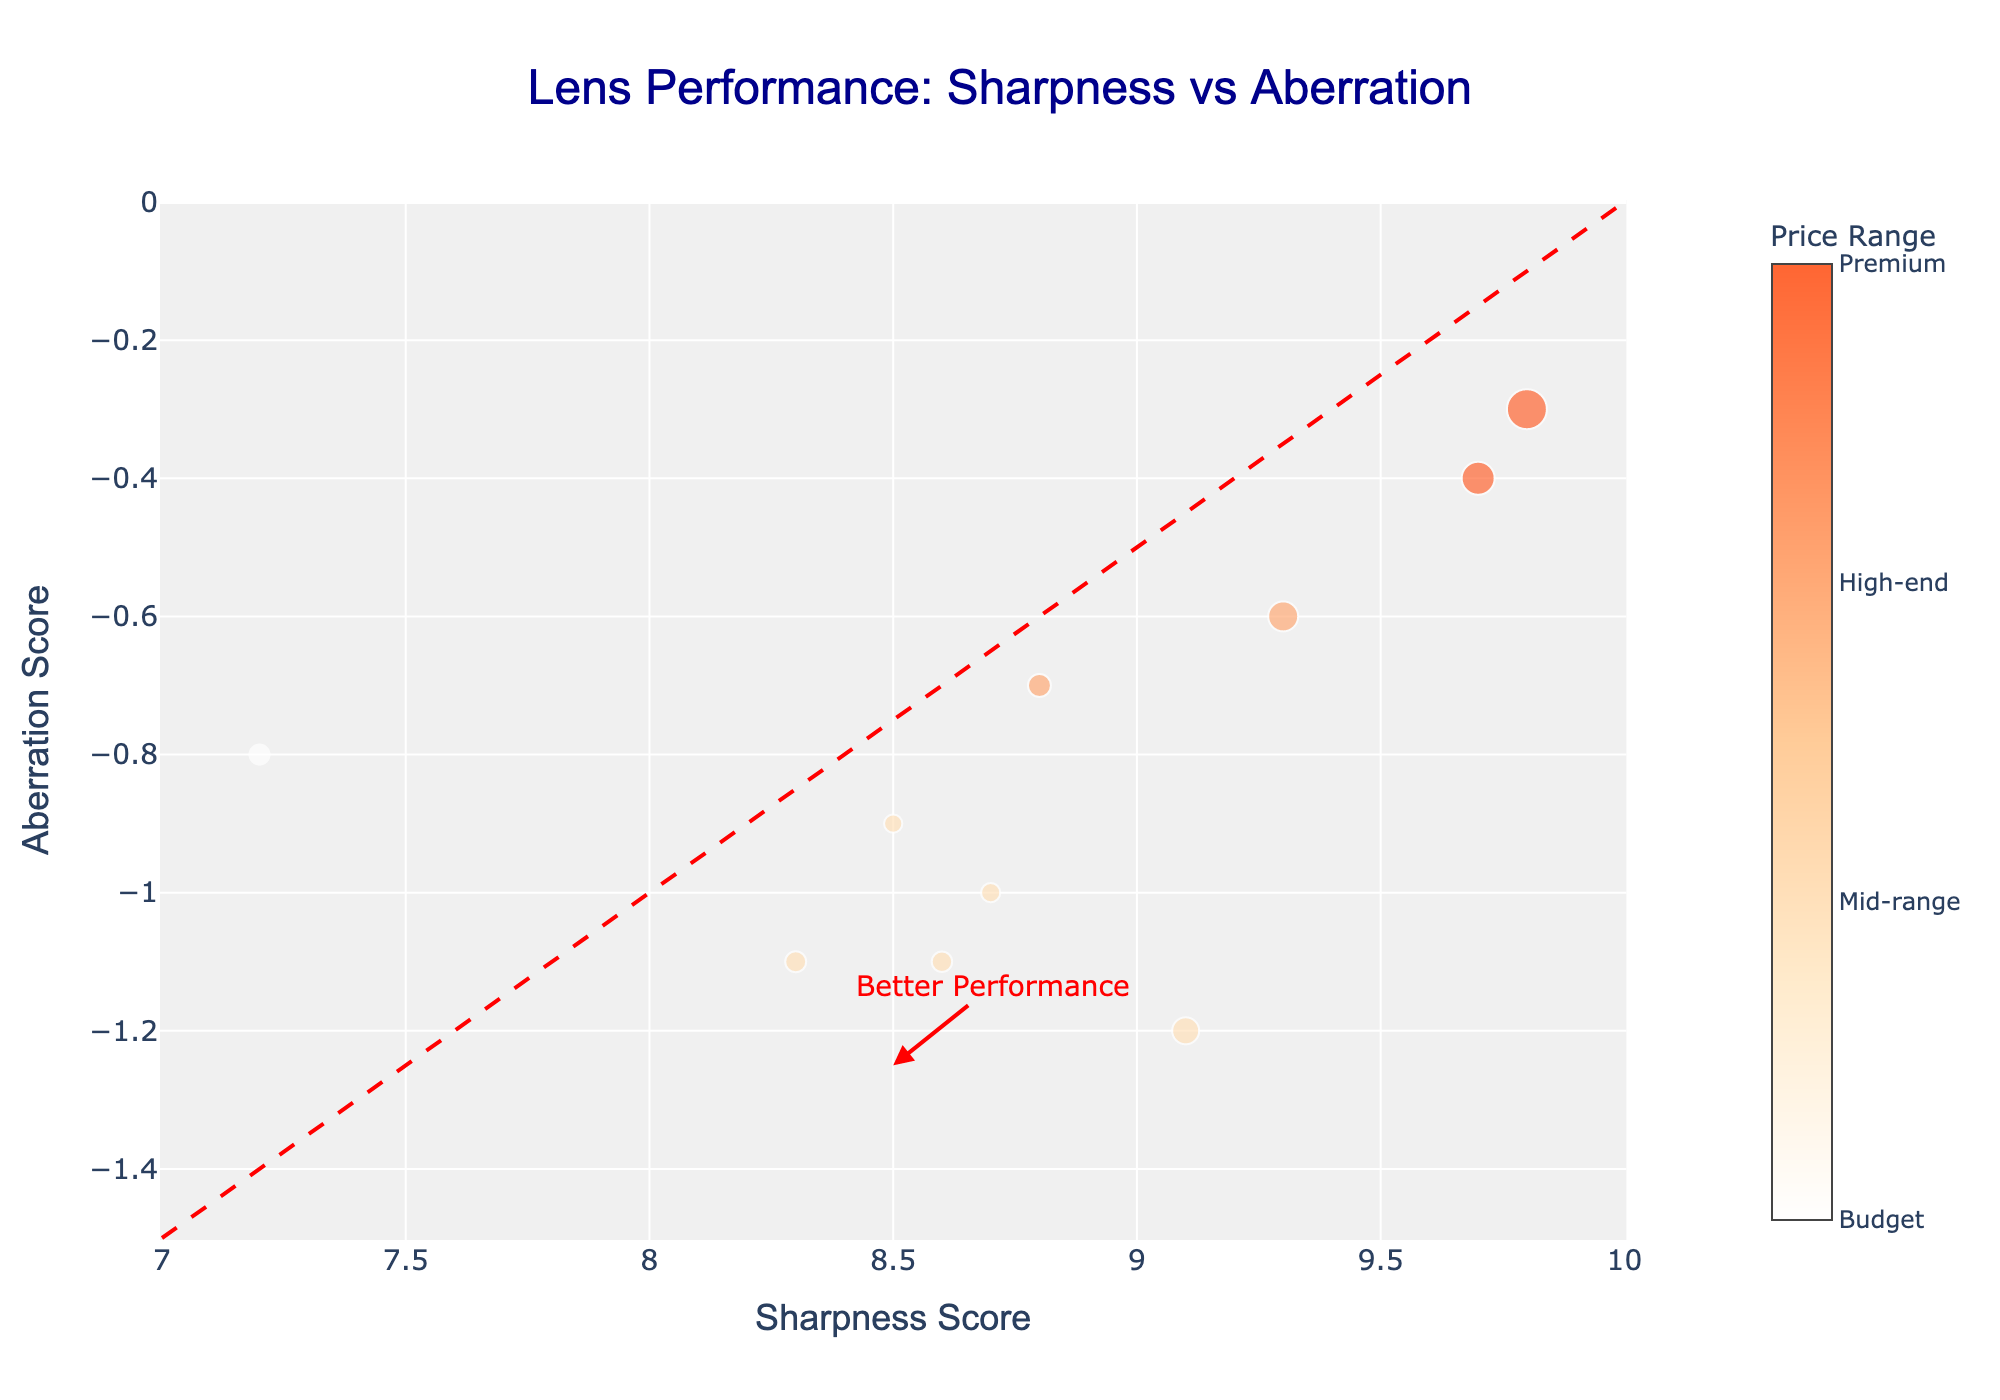What's the title of the plot? The title is located at the top center of the figure, written in a larger and bold font. It reads "Lens Performance: Sharpness vs Aberration".
Answer: Lens Performance: Sharpness vs Aberration What is the range of Sharpness Scores visible on the x-axis? The x-axis range is shown at the bottom of the plot, with markings running from 7 to 10.
Answer: 7 to 10 Which lens has the highest sharpness score? The data points are distributed along the x-axis according to sharpness scores. The lens at the far right-end of the x-axis has the highest score. According to the hover text, this lens is the Leica Summilux-M 50mm f/1.4 ASPH.
Answer: Leica Summilux-M 50mm f/1.4 ASPH Which lens belongs to the 'Budget' price range and what are its sharpness and aberration scores? The color scale indicates that lenses in the budget range are colored differently from others. Identifying this lens on the plot gives us the sharpness and aberration values from its position. The Canon EF 50mm f/1.8 STM is in the Budget range, with a sharpness score of around 7.2 and an aberration score of -0.8.
Answer: Canon EF 50mm f/1.8 STM, 7.2, -0.8 How many lenses are in the 'Premium' price range? The color scale bar at the right indicates which color corresponds to the 'Premium' range. Count the data points in the graph that match this color. There are 2 lenses in the Premium range: Zeiss Milvus 35mm f/1.4 and Leica Summilux-M 50mm f/1.4 ASPH.
Answer: 2 What does a higher marker size represent in this plot? The legend does not show marker sizes, but the code indicates the size is proportional to the -log10(p-value). Larger markers correspond to smaller p-values.
Answer: Smaller p-values Compare the sharpness and aberration scores of the Sigma 35mm f/1.4 DG HSM Art and the Sony FE 24-105mm f/4 G OSS. Which one performs better? The Sigma 35mm f/1.4 DG HSM Art has a sharpness score of 9.1 and an aberration score of -1.2. The Sony FE 24-105mm f/4 G OSS has a sharpness score of 8.8 and an aberration score of -0.7. Since lower aberration and higher sharpness indicate better performance, the Sigma lens performs better in sharpness but worse in aberration when compared to the Sony lens.
Answer: Sigma performs better in sharpness, Sony performs better in aberration What is the annotation pointing to in the plot and what does it explain? The annotation points to a region in the plot that signifies better lens performance, located where sharpness scores are high and aberration scores are low (i.e., upper right).
Answer: Better Performance Which lens has the lowest p-value and what does its marker size indicate? The Leica Summilux-M 50mm f/1.4 ASPH has the lowest p-value, indicated by the largest marker size. A smaller p-value indicates higher statistical significance.
Answer: Leica Summilux-M 50mm f/1.4 ASPH, highest significance 